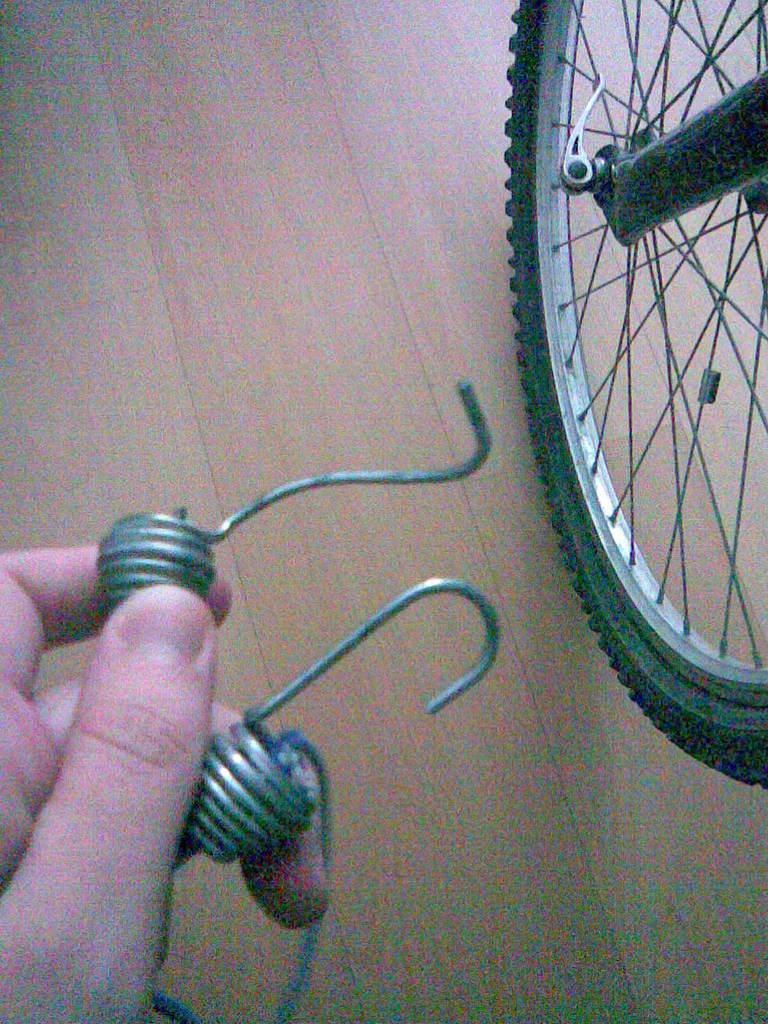What object from a bicycle can be seen on the floor in the image? There is a wheel of a bicycle on the floor in the image. What is the color of the floor in the image? The floor is in cream color. What is the human hand holding in the image? The human hand is holding two springs in the image. What is the distribution of bikes on the moon in the image? There is no mention of the moon or bikes in the image, so we cannot determine the distribution of bikes on the moon. 